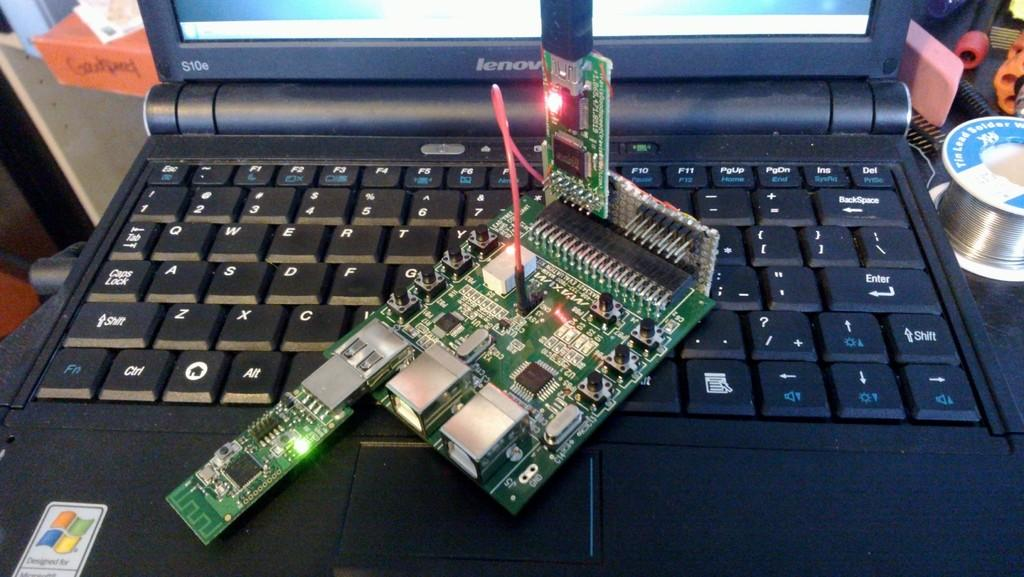<image>
Give a short and clear explanation of the subsequent image. A Lenovo laptop model S10e is being worked on. 